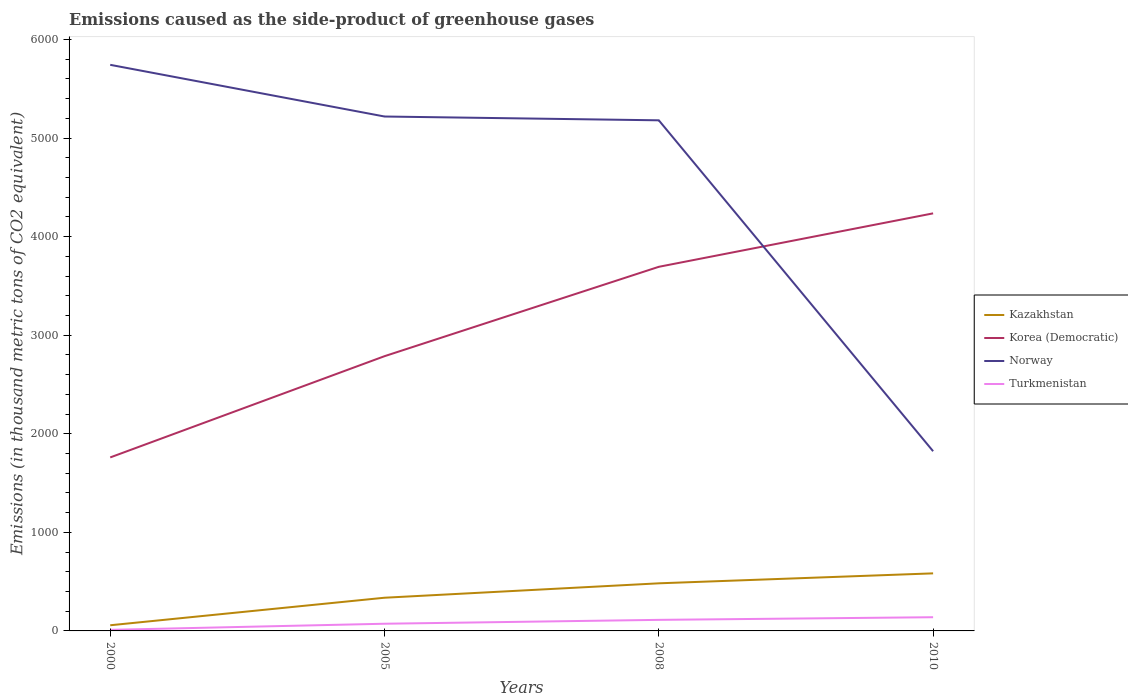How many different coloured lines are there?
Provide a short and direct response. 4. In which year was the emissions caused as the side-product of greenhouse gases in Korea (Democratic) maximum?
Provide a succinct answer. 2000. What is the total emissions caused as the side-product of greenhouse gases in Korea (Democratic) in the graph?
Provide a succinct answer. -1027. What is the difference between the highest and the second highest emissions caused as the side-product of greenhouse gases in Kazakhstan?
Ensure brevity in your answer.  526.5. What is the difference between the highest and the lowest emissions caused as the side-product of greenhouse gases in Kazakhstan?
Your response must be concise. 2. Is the emissions caused as the side-product of greenhouse gases in Korea (Democratic) strictly greater than the emissions caused as the side-product of greenhouse gases in Norway over the years?
Your response must be concise. No. How many lines are there?
Ensure brevity in your answer.  4. How many years are there in the graph?
Your answer should be compact. 4. What is the difference between two consecutive major ticks on the Y-axis?
Your response must be concise. 1000. Are the values on the major ticks of Y-axis written in scientific E-notation?
Provide a short and direct response. No. Does the graph contain any zero values?
Provide a short and direct response. No. Does the graph contain grids?
Offer a very short reply. No. How many legend labels are there?
Offer a very short reply. 4. What is the title of the graph?
Provide a short and direct response. Emissions caused as the side-product of greenhouse gases. Does "Azerbaijan" appear as one of the legend labels in the graph?
Offer a terse response. No. What is the label or title of the X-axis?
Provide a succinct answer. Years. What is the label or title of the Y-axis?
Offer a terse response. Emissions (in thousand metric tons of CO2 equivalent). What is the Emissions (in thousand metric tons of CO2 equivalent) in Kazakhstan in 2000?
Ensure brevity in your answer.  57.5. What is the Emissions (in thousand metric tons of CO2 equivalent) of Korea (Democratic) in 2000?
Your answer should be compact. 1760.1. What is the Emissions (in thousand metric tons of CO2 equivalent) in Norway in 2000?
Keep it short and to the point. 5742.8. What is the Emissions (in thousand metric tons of CO2 equivalent) of Turkmenistan in 2000?
Offer a terse response. 10.9. What is the Emissions (in thousand metric tons of CO2 equivalent) in Kazakhstan in 2005?
Offer a terse response. 336.7. What is the Emissions (in thousand metric tons of CO2 equivalent) of Korea (Democratic) in 2005?
Provide a short and direct response. 2787.1. What is the Emissions (in thousand metric tons of CO2 equivalent) in Norway in 2005?
Provide a succinct answer. 5218.5. What is the Emissions (in thousand metric tons of CO2 equivalent) of Turkmenistan in 2005?
Your response must be concise. 72.9. What is the Emissions (in thousand metric tons of CO2 equivalent) of Kazakhstan in 2008?
Make the answer very short. 482.9. What is the Emissions (in thousand metric tons of CO2 equivalent) in Korea (Democratic) in 2008?
Give a very brief answer. 3693.8. What is the Emissions (in thousand metric tons of CO2 equivalent) in Norway in 2008?
Your answer should be compact. 5179.9. What is the Emissions (in thousand metric tons of CO2 equivalent) of Turkmenistan in 2008?
Provide a succinct answer. 112.2. What is the Emissions (in thousand metric tons of CO2 equivalent) in Kazakhstan in 2010?
Keep it short and to the point. 584. What is the Emissions (in thousand metric tons of CO2 equivalent) in Korea (Democratic) in 2010?
Provide a short and direct response. 4236. What is the Emissions (in thousand metric tons of CO2 equivalent) of Norway in 2010?
Provide a short and direct response. 1823. What is the Emissions (in thousand metric tons of CO2 equivalent) of Turkmenistan in 2010?
Your answer should be compact. 139. Across all years, what is the maximum Emissions (in thousand metric tons of CO2 equivalent) in Kazakhstan?
Give a very brief answer. 584. Across all years, what is the maximum Emissions (in thousand metric tons of CO2 equivalent) of Korea (Democratic)?
Your answer should be compact. 4236. Across all years, what is the maximum Emissions (in thousand metric tons of CO2 equivalent) of Norway?
Offer a terse response. 5742.8. Across all years, what is the maximum Emissions (in thousand metric tons of CO2 equivalent) of Turkmenistan?
Your answer should be very brief. 139. Across all years, what is the minimum Emissions (in thousand metric tons of CO2 equivalent) of Kazakhstan?
Ensure brevity in your answer.  57.5. Across all years, what is the minimum Emissions (in thousand metric tons of CO2 equivalent) in Korea (Democratic)?
Your answer should be compact. 1760.1. Across all years, what is the minimum Emissions (in thousand metric tons of CO2 equivalent) of Norway?
Offer a very short reply. 1823. What is the total Emissions (in thousand metric tons of CO2 equivalent) in Kazakhstan in the graph?
Make the answer very short. 1461.1. What is the total Emissions (in thousand metric tons of CO2 equivalent) in Korea (Democratic) in the graph?
Give a very brief answer. 1.25e+04. What is the total Emissions (in thousand metric tons of CO2 equivalent) in Norway in the graph?
Offer a terse response. 1.80e+04. What is the total Emissions (in thousand metric tons of CO2 equivalent) in Turkmenistan in the graph?
Offer a terse response. 335. What is the difference between the Emissions (in thousand metric tons of CO2 equivalent) of Kazakhstan in 2000 and that in 2005?
Offer a terse response. -279.2. What is the difference between the Emissions (in thousand metric tons of CO2 equivalent) of Korea (Democratic) in 2000 and that in 2005?
Provide a succinct answer. -1027. What is the difference between the Emissions (in thousand metric tons of CO2 equivalent) of Norway in 2000 and that in 2005?
Keep it short and to the point. 524.3. What is the difference between the Emissions (in thousand metric tons of CO2 equivalent) in Turkmenistan in 2000 and that in 2005?
Provide a succinct answer. -62. What is the difference between the Emissions (in thousand metric tons of CO2 equivalent) in Kazakhstan in 2000 and that in 2008?
Make the answer very short. -425.4. What is the difference between the Emissions (in thousand metric tons of CO2 equivalent) of Korea (Democratic) in 2000 and that in 2008?
Your response must be concise. -1933.7. What is the difference between the Emissions (in thousand metric tons of CO2 equivalent) in Norway in 2000 and that in 2008?
Provide a succinct answer. 562.9. What is the difference between the Emissions (in thousand metric tons of CO2 equivalent) of Turkmenistan in 2000 and that in 2008?
Keep it short and to the point. -101.3. What is the difference between the Emissions (in thousand metric tons of CO2 equivalent) in Kazakhstan in 2000 and that in 2010?
Your answer should be very brief. -526.5. What is the difference between the Emissions (in thousand metric tons of CO2 equivalent) of Korea (Democratic) in 2000 and that in 2010?
Keep it short and to the point. -2475.9. What is the difference between the Emissions (in thousand metric tons of CO2 equivalent) in Norway in 2000 and that in 2010?
Offer a very short reply. 3919.8. What is the difference between the Emissions (in thousand metric tons of CO2 equivalent) in Turkmenistan in 2000 and that in 2010?
Offer a very short reply. -128.1. What is the difference between the Emissions (in thousand metric tons of CO2 equivalent) of Kazakhstan in 2005 and that in 2008?
Your answer should be very brief. -146.2. What is the difference between the Emissions (in thousand metric tons of CO2 equivalent) of Korea (Democratic) in 2005 and that in 2008?
Provide a short and direct response. -906.7. What is the difference between the Emissions (in thousand metric tons of CO2 equivalent) in Norway in 2005 and that in 2008?
Your answer should be very brief. 38.6. What is the difference between the Emissions (in thousand metric tons of CO2 equivalent) of Turkmenistan in 2005 and that in 2008?
Offer a terse response. -39.3. What is the difference between the Emissions (in thousand metric tons of CO2 equivalent) of Kazakhstan in 2005 and that in 2010?
Provide a short and direct response. -247.3. What is the difference between the Emissions (in thousand metric tons of CO2 equivalent) of Korea (Democratic) in 2005 and that in 2010?
Offer a terse response. -1448.9. What is the difference between the Emissions (in thousand metric tons of CO2 equivalent) of Norway in 2005 and that in 2010?
Provide a short and direct response. 3395.5. What is the difference between the Emissions (in thousand metric tons of CO2 equivalent) in Turkmenistan in 2005 and that in 2010?
Provide a short and direct response. -66.1. What is the difference between the Emissions (in thousand metric tons of CO2 equivalent) in Kazakhstan in 2008 and that in 2010?
Make the answer very short. -101.1. What is the difference between the Emissions (in thousand metric tons of CO2 equivalent) in Korea (Democratic) in 2008 and that in 2010?
Give a very brief answer. -542.2. What is the difference between the Emissions (in thousand metric tons of CO2 equivalent) of Norway in 2008 and that in 2010?
Offer a terse response. 3356.9. What is the difference between the Emissions (in thousand metric tons of CO2 equivalent) of Turkmenistan in 2008 and that in 2010?
Keep it short and to the point. -26.8. What is the difference between the Emissions (in thousand metric tons of CO2 equivalent) of Kazakhstan in 2000 and the Emissions (in thousand metric tons of CO2 equivalent) of Korea (Democratic) in 2005?
Provide a succinct answer. -2729.6. What is the difference between the Emissions (in thousand metric tons of CO2 equivalent) of Kazakhstan in 2000 and the Emissions (in thousand metric tons of CO2 equivalent) of Norway in 2005?
Keep it short and to the point. -5161. What is the difference between the Emissions (in thousand metric tons of CO2 equivalent) of Kazakhstan in 2000 and the Emissions (in thousand metric tons of CO2 equivalent) of Turkmenistan in 2005?
Provide a short and direct response. -15.4. What is the difference between the Emissions (in thousand metric tons of CO2 equivalent) of Korea (Democratic) in 2000 and the Emissions (in thousand metric tons of CO2 equivalent) of Norway in 2005?
Your answer should be very brief. -3458.4. What is the difference between the Emissions (in thousand metric tons of CO2 equivalent) of Korea (Democratic) in 2000 and the Emissions (in thousand metric tons of CO2 equivalent) of Turkmenistan in 2005?
Give a very brief answer. 1687.2. What is the difference between the Emissions (in thousand metric tons of CO2 equivalent) in Norway in 2000 and the Emissions (in thousand metric tons of CO2 equivalent) in Turkmenistan in 2005?
Your answer should be very brief. 5669.9. What is the difference between the Emissions (in thousand metric tons of CO2 equivalent) of Kazakhstan in 2000 and the Emissions (in thousand metric tons of CO2 equivalent) of Korea (Democratic) in 2008?
Keep it short and to the point. -3636.3. What is the difference between the Emissions (in thousand metric tons of CO2 equivalent) of Kazakhstan in 2000 and the Emissions (in thousand metric tons of CO2 equivalent) of Norway in 2008?
Offer a very short reply. -5122.4. What is the difference between the Emissions (in thousand metric tons of CO2 equivalent) in Kazakhstan in 2000 and the Emissions (in thousand metric tons of CO2 equivalent) in Turkmenistan in 2008?
Offer a very short reply. -54.7. What is the difference between the Emissions (in thousand metric tons of CO2 equivalent) of Korea (Democratic) in 2000 and the Emissions (in thousand metric tons of CO2 equivalent) of Norway in 2008?
Provide a succinct answer. -3419.8. What is the difference between the Emissions (in thousand metric tons of CO2 equivalent) of Korea (Democratic) in 2000 and the Emissions (in thousand metric tons of CO2 equivalent) of Turkmenistan in 2008?
Your answer should be compact. 1647.9. What is the difference between the Emissions (in thousand metric tons of CO2 equivalent) of Norway in 2000 and the Emissions (in thousand metric tons of CO2 equivalent) of Turkmenistan in 2008?
Provide a succinct answer. 5630.6. What is the difference between the Emissions (in thousand metric tons of CO2 equivalent) in Kazakhstan in 2000 and the Emissions (in thousand metric tons of CO2 equivalent) in Korea (Democratic) in 2010?
Your answer should be very brief. -4178.5. What is the difference between the Emissions (in thousand metric tons of CO2 equivalent) in Kazakhstan in 2000 and the Emissions (in thousand metric tons of CO2 equivalent) in Norway in 2010?
Your answer should be compact. -1765.5. What is the difference between the Emissions (in thousand metric tons of CO2 equivalent) of Kazakhstan in 2000 and the Emissions (in thousand metric tons of CO2 equivalent) of Turkmenistan in 2010?
Ensure brevity in your answer.  -81.5. What is the difference between the Emissions (in thousand metric tons of CO2 equivalent) in Korea (Democratic) in 2000 and the Emissions (in thousand metric tons of CO2 equivalent) in Norway in 2010?
Offer a very short reply. -62.9. What is the difference between the Emissions (in thousand metric tons of CO2 equivalent) of Korea (Democratic) in 2000 and the Emissions (in thousand metric tons of CO2 equivalent) of Turkmenistan in 2010?
Provide a short and direct response. 1621.1. What is the difference between the Emissions (in thousand metric tons of CO2 equivalent) of Norway in 2000 and the Emissions (in thousand metric tons of CO2 equivalent) of Turkmenistan in 2010?
Your answer should be compact. 5603.8. What is the difference between the Emissions (in thousand metric tons of CO2 equivalent) of Kazakhstan in 2005 and the Emissions (in thousand metric tons of CO2 equivalent) of Korea (Democratic) in 2008?
Ensure brevity in your answer.  -3357.1. What is the difference between the Emissions (in thousand metric tons of CO2 equivalent) in Kazakhstan in 2005 and the Emissions (in thousand metric tons of CO2 equivalent) in Norway in 2008?
Provide a succinct answer. -4843.2. What is the difference between the Emissions (in thousand metric tons of CO2 equivalent) in Kazakhstan in 2005 and the Emissions (in thousand metric tons of CO2 equivalent) in Turkmenistan in 2008?
Your response must be concise. 224.5. What is the difference between the Emissions (in thousand metric tons of CO2 equivalent) of Korea (Democratic) in 2005 and the Emissions (in thousand metric tons of CO2 equivalent) of Norway in 2008?
Offer a very short reply. -2392.8. What is the difference between the Emissions (in thousand metric tons of CO2 equivalent) in Korea (Democratic) in 2005 and the Emissions (in thousand metric tons of CO2 equivalent) in Turkmenistan in 2008?
Give a very brief answer. 2674.9. What is the difference between the Emissions (in thousand metric tons of CO2 equivalent) in Norway in 2005 and the Emissions (in thousand metric tons of CO2 equivalent) in Turkmenistan in 2008?
Offer a terse response. 5106.3. What is the difference between the Emissions (in thousand metric tons of CO2 equivalent) of Kazakhstan in 2005 and the Emissions (in thousand metric tons of CO2 equivalent) of Korea (Democratic) in 2010?
Offer a terse response. -3899.3. What is the difference between the Emissions (in thousand metric tons of CO2 equivalent) of Kazakhstan in 2005 and the Emissions (in thousand metric tons of CO2 equivalent) of Norway in 2010?
Keep it short and to the point. -1486.3. What is the difference between the Emissions (in thousand metric tons of CO2 equivalent) in Kazakhstan in 2005 and the Emissions (in thousand metric tons of CO2 equivalent) in Turkmenistan in 2010?
Provide a succinct answer. 197.7. What is the difference between the Emissions (in thousand metric tons of CO2 equivalent) of Korea (Democratic) in 2005 and the Emissions (in thousand metric tons of CO2 equivalent) of Norway in 2010?
Your answer should be compact. 964.1. What is the difference between the Emissions (in thousand metric tons of CO2 equivalent) in Korea (Democratic) in 2005 and the Emissions (in thousand metric tons of CO2 equivalent) in Turkmenistan in 2010?
Give a very brief answer. 2648.1. What is the difference between the Emissions (in thousand metric tons of CO2 equivalent) of Norway in 2005 and the Emissions (in thousand metric tons of CO2 equivalent) of Turkmenistan in 2010?
Offer a very short reply. 5079.5. What is the difference between the Emissions (in thousand metric tons of CO2 equivalent) in Kazakhstan in 2008 and the Emissions (in thousand metric tons of CO2 equivalent) in Korea (Democratic) in 2010?
Make the answer very short. -3753.1. What is the difference between the Emissions (in thousand metric tons of CO2 equivalent) of Kazakhstan in 2008 and the Emissions (in thousand metric tons of CO2 equivalent) of Norway in 2010?
Provide a short and direct response. -1340.1. What is the difference between the Emissions (in thousand metric tons of CO2 equivalent) of Kazakhstan in 2008 and the Emissions (in thousand metric tons of CO2 equivalent) of Turkmenistan in 2010?
Your answer should be very brief. 343.9. What is the difference between the Emissions (in thousand metric tons of CO2 equivalent) of Korea (Democratic) in 2008 and the Emissions (in thousand metric tons of CO2 equivalent) of Norway in 2010?
Offer a terse response. 1870.8. What is the difference between the Emissions (in thousand metric tons of CO2 equivalent) of Korea (Democratic) in 2008 and the Emissions (in thousand metric tons of CO2 equivalent) of Turkmenistan in 2010?
Provide a short and direct response. 3554.8. What is the difference between the Emissions (in thousand metric tons of CO2 equivalent) of Norway in 2008 and the Emissions (in thousand metric tons of CO2 equivalent) of Turkmenistan in 2010?
Your response must be concise. 5040.9. What is the average Emissions (in thousand metric tons of CO2 equivalent) in Kazakhstan per year?
Your answer should be very brief. 365.27. What is the average Emissions (in thousand metric tons of CO2 equivalent) of Korea (Democratic) per year?
Offer a very short reply. 3119.25. What is the average Emissions (in thousand metric tons of CO2 equivalent) in Norway per year?
Offer a very short reply. 4491.05. What is the average Emissions (in thousand metric tons of CO2 equivalent) of Turkmenistan per year?
Provide a short and direct response. 83.75. In the year 2000, what is the difference between the Emissions (in thousand metric tons of CO2 equivalent) of Kazakhstan and Emissions (in thousand metric tons of CO2 equivalent) of Korea (Democratic)?
Your answer should be very brief. -1702.6. In the year 2000, what is the difference between the Emissions (in thousand metric tons of CO2 equivalent) of Kazakhstan and Emissions (in thousand metric tons of CO2 equivalent) of Norway?
Keep it short and to the point. -5685.3. In the year 2000, what is the difference between the Emissions (in thousand metric tons of CO2 equivalent) of Kazakhstan and Emissions (in thousand metric tons of CO2 equivalent) of Turkmenistan?
Offer a very short reply. 46.6. In the year 2000, what is the difference between the Emissions (in thousand metric tons of CO2 equivalent) of Korea (Democratic) and Emissions (in thousand metric tons of CO2 equivalent) of Norway?
Your answer should be compact. -3982.7. In the year 2000, what is the difference between the Emissions (in thousand metric tons of CO2 equivalent) of Korea (Democratic) and Emissions (in thousand metric tons of CO2 equivalent) of Turkmenistan?
Offer a very short reply. 1749.2. In the year 2000, what is the difference between the Emissions (in thousand metric tons of CO2 equivalent) of Norway and Emissions (in thousand metric tons of CO2 equivalent) of Turkmenistan?
Give a very brief answer. 5731.9. In the year 2005, what is the difference between the Emissions (in thousand metric tons of CO2 equivalent) of Kazakhstan and Emissions (in thousand metric tons of CO2 equivalent) of Korea (Democratic)?
Your answer should be compact. -2450.4. In the year 2005, what is the difference between the Emissions (in thousand metric tons of CO2 equivalent) of Kazakhstan and Emissions (in thousand metric tons of CO2 equivalent) of Norway?
Provide a short and direct response. -4881.8. In the year 2005, what is the difference between the Emissions (in thousand metric tons of CO2 equivalent) in Kazakhstan and Emissions (in thousand metric tons of CO2 equivalent) in Turkmenistan?
Make the answer very short. 263.8. In the year 2005, what is the difference between the Emissions (in thousand metric tons of CO2 equivalent) in Korea (Democratic) and Emissions (in thousand metric tons of CO2 equivalent) in Norway?
Your response must be concise. -2431.4. In the year 2005, what is the difference between the Emissions (in thousand metric tons of CO2 equivalent) of Korea (Democratic) and Emissions (in thousand metric tons of CO2 equivalent) of Turkmenistan?
Your response must be concise. 2714.2. In the year 2005, what is the difference between the Emissions (in thousand metric tons of CO2 equivalent) in Norway and Emissions (in thousand metric tons of CO2 equivalent) in Turkmenistan?
Offer a terse response. 5145.6. In the year 2008, what is the difference between the Emissions (in thousand metric tons of CO2 equivalent) in Kazakhstan and Emissions (in thousand metric tons of CO2 equivalent) in Korea (Democratic)?
Your answer should be compact. -3210.9. In the year 2008, what is the difference between the Emissions (in thousand metric tons of CO2 equivalent) of Kazakhstan and Emissions (in thousand metric tons of CO2 equivalent) of Norway?
Give a very brief answer. -4697. In the year 2008, what is the difference between the Emissions (in thousand metric tons of CO2 equivalent) in Kazakhstan and Emissions (in thousand metric tons of CO2 equivalent) in Turkmenistan?
Give a very brief answer. 370.7. In the year 2008, what is the difference between the Emissions (in thousand metric tons of CO2 equivalent) of Korea (Democratic) and Emissions (in thousand metric tons of CO2 equivalent) of Norway?
Keep it short and to the point. -1486.1. In the year 2008, what is the difference between the Emissions (in thousand metric tons of CO2 equivalent) in Korea (Democratic) and Emissions (in thousand metric tons of CO2 equivalent) in Turkmenistan?
Make the answer very short. 3581.6. In the year 2008, what is the difference between the Emissions (in thousand metric tons of CO2 equivalent) in Norway and Emissions (in thousand metric tons of CO2 equivalent) in Turkmenistan?
Your response must be concise. 5067.7. In the year 2010, what is the difference between the Emissions (in thousand metric tons of CO2 equivalent) of Kazakhstan and Emissions (in thousand metric tons of CO2 equivalent) of Korea (Democratic)?
Offer a very short reply. -3652. In the year 2010, what is the difference between the Emissions (in thousand metric tons of CO2 equivalent) in Kazakhstan and Emissions (in thousand metric tons of CO2 equivalent) in Norway?
Offer a very short reply. -1239. In the year 2010, what is the difference between the Emissions (in thousand metric tons of CO2 equivalent) of Kazakhstan and Emissions (in thousand metric tons of CO2 equivalent) of Turkmenistan?
Your response must be concise. 445. In the year 2010, what is the difference between the Emissions (in thousand metric tons of CO2 equivalent) in Korea (Democratic) and Emissions (in thousand metric tons of CO2 equivalent) in Norway?
Keep it short and to the point. 2413. In the year 2010, what is the difference between the Emissions (in thousand metric tons of CO2 equivalent) in Korea (Democratic) and Emissions (in thousand metric tons of CO2 equivalent) in Turkmenistan?
Make the answer very short. 4097. In the year 2010, what is the difference between the Emissions (in thousand metric tons of CO2 equivalent) of Norway and Emissions (in thousand metric tons of CO2 equivalent) of Turkmenistan?
Give a very brief answer. 1684. What is the ratio of the Emissions (in thousand metric tons of CO2 equivalent) in Kazakhstan in 2000 to that in 2005?
Offer a terse response. 0.17. What is the ratio of the Emissions (in thousand metric tons of CO2 equivalent) of Korea (Democratic) in 2000 to that in 2005?
Your answer should be compact. 0.63. What is the ratio of the Emissions (in thousand metric tons of CO2 equivalent) in Norway in 2000 to that in 2005?
Your response must be concise. 1.1. What is the ratio of the Emissions (in thousand metric tons of CO2 equivalent) in Turkmenistan in 2000 to that in 2005?
Provide a succinct answer. 0.15. What is the ratio of the Emissions (in thousand metric tons of CO2 equivalent) of Kazakhstan in 2000 to that in 2008?
Keep it short and to the point. 0.12. What is the ratio of the Emissions (in thousand metric tons of CO2 equivalent) of Korea (Democratic) in 2000 to that in 2008?
Give a very brief answer. 0.48. What is the ratio of the Emissions (in thousand metric tons of CO2 equivalent) in Norway in 2000 to that in 2008?
Make the answer very short. 1.11. What is the ratio of the Emissions (in thousand metric tons of CO2 equivalent) in Turkmenistan in 2000 to that in 2008?
Your response must be concise. 0.1. What is the ratio of the Emissions (in thousand metric tons of CO2 equivalent) in Kazakhstan in 2000 to that in 2010?
Offer a very short reply. 0.1. What is the ratio of the Emissions (in thousand metric tons of CO2 equivalent) of Korea (Democratic) in 2000 to that in 2010?
Offer a terse response. 0.42. What is the ratio of the Emissions (in thousand metric tons of CO2 equivalent) of Norway in 2000 to that in 2010?
Your answer should be very brief. 3.15. What is the ratio of the Emissions (in thousand metric tons of CO2 equivalent) in Turkmenistan in 2000 to that in 2010?
Keep it short and to the point. 0.08. What is the ratio of the Emissions (in thousand metric tons of CO2 equivalent) of Kazakhstan in 2005 to that in 2008?
Offer a terse response. 0.7. What is the ratio of the Emissions (in thousand metric tons of CO2 equivalent) of Korea (Democratic) in 2005 to that in 2008?
Offer a terse response. 0.75. What is the ratio of the Emissions (in thousand metric tons of CO2 equivalent) of Norway in 2005 to that in 2008?
Offer a very short reply. 1.01. What is the ratio of the Emissions (in thousand metric tons of CO2 equivalent) in Turkmenistan in 2005 to that in 2008?
Make the answer very short. 0.65. What is the ratio of the Emissions (in thousand metric tons of CO2 equivalent) in Kazakhstan in 2005 to that in 2010?
Provide a succinct answer. 0.58. What is the ratio of the Emissions (in thousand metric tons of CO2 equivalent) in Korea (Democratic) in 2005 to that in 2010?
Your response must be concise. 0.66. What is the ratio of the Emissions (in thousand metric tons of CO2 equivalent) of Norway in 2005 to that in 2010?
Keep it short and to the point. 2.86. What is the ratio of the Emissions (in thousand metric tons of CO2 equivalent) of Turkmenistan in 2005 to that in 2010?
Give a very brief answer. 0.52. What is the ratio of the Emissions (in thousand metric tons of CO2 equivalent) in Kazakhstan in 2008 to that in 2010?
Make the answer very short. 0.83. What is the ratio of the Emissions (in thousand metric tons of CO2 equivalent) in Korea (Democratic) in 2008 to that in 2010?
Keep it short and to the point. 0.87. What is the ratio of the Emissions (in thousand metric tons of CO2 equivalent) of Norway in 2008 to that in 2010?
Your answer should be very brief. 2.84. What is the ratio of the Emissions (in thousand metric tons of CO2 equivalent) in Turkmenistan in 2008 to that in 2010?
Make the answer very short. 0.81. What is the difference between the highest and the second highest Emissions (in thousand metric tons of CO2 equivalent) in Kazakhstan?
Your answer should be very brief. 101.1. What is the difference between the highest and the second highest Emissions (in thousand metric tons of CO2 equivalent) of Korea (Democratic)?
Offer a very short reply. 542.2. What is the difference between the highest and the second highest Emissions (in thousand metric tons of CO2 equivalent) of Norway?
Give a very brief answer. 524.3. What is the difference between the highest and the second highest Emissions (in thousand metric tons of CO2 equivalent) of Turkmenistan?
Provide a succinct answer. 26.8. What is the difference between the highest and the lowest Emissions (in thousand metric tons of CO2 equivalent) in Kazakhstan?
Your answer should be compact. 526.5. What is the difference between the highest and the lowest Emissions (in thousand metric tons of CO2 equivalent) in Korea (Democratic)?
Your answer should be very brief. 2475.9. What is the difference between the highest and the lowest Emissions (in thousand metric tons of CO2 equivalent) in Norway?
Offer a very short reply. 3919.8. What is the difference between the highest and the lowest Emissions (in thousand metric tons of CO2 equivalent) of Turkmenistan?
Your answer should be very brief. 128.1. 